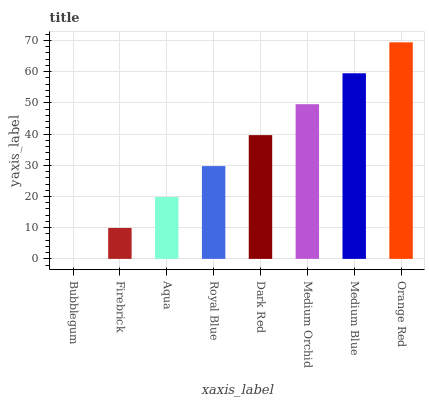Is Bubblegum the minimum?
Answer yes or no. Yes. Is Orange Red the maximum?
Answer yes or no. Yes. Is Firebrick the minimum?
Answer yes or no. No. Is Firebrick the maximum?
Answer yes or no. No. Is Firebrick greater than Bubblegum?
Answer yes or no. Yes. Is Bubblegum less than Firebrick?
Answer yes or no. Yes. Is Bubblegum greater than Firebrick?
Answer yes or no. No. Is Firebrick less than Bubblegum?
Answer yes or no. No. Is Dark Red the high median?
Answer yes or no. Yes. Is Royal Blue the low median?
Answer yes or no. Yes. Is Royal Blue the high median?
Answer yes or no. No. Is Medium Orchid the low median?
Answer yes or no. No. 